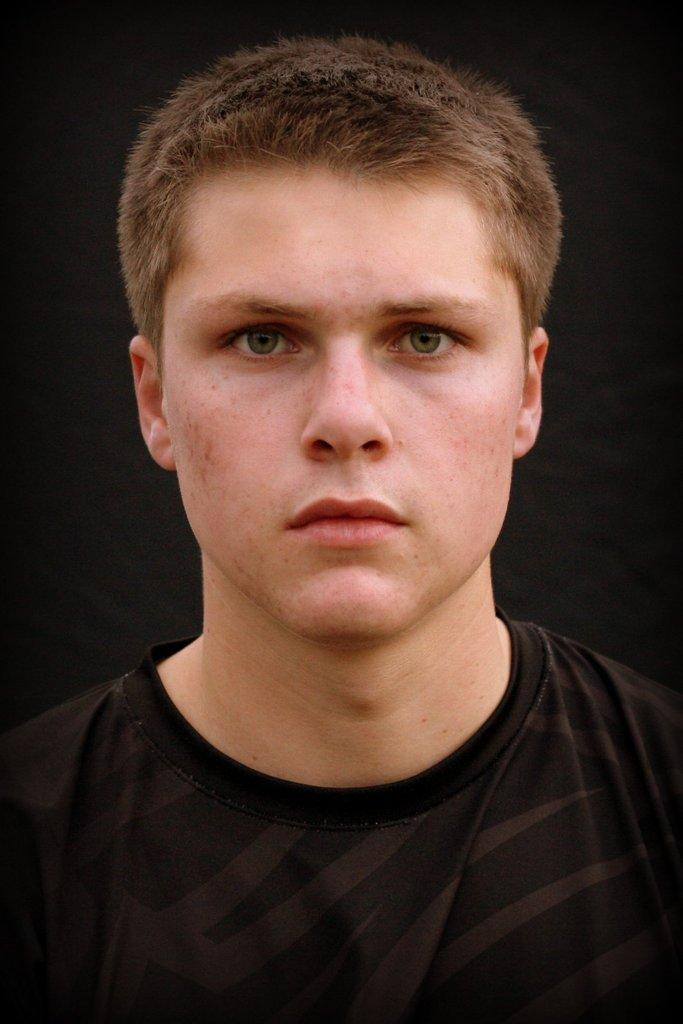Who or what is the main subject of the image? There is a person in the image. What is the person wearing? The person is wearing a dress. What color is the background of the image? The background of the image is black. What type of joke is the person telling in the image? There is no indication in the image that the person is telling a joke, so it cannot be determined from the picture. 